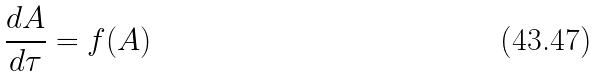Convert formula to latex. <formula><loc_0><loc_0><loc_500><loc_500>\frac { d A } { d \tau } = f ( A )</formula> 